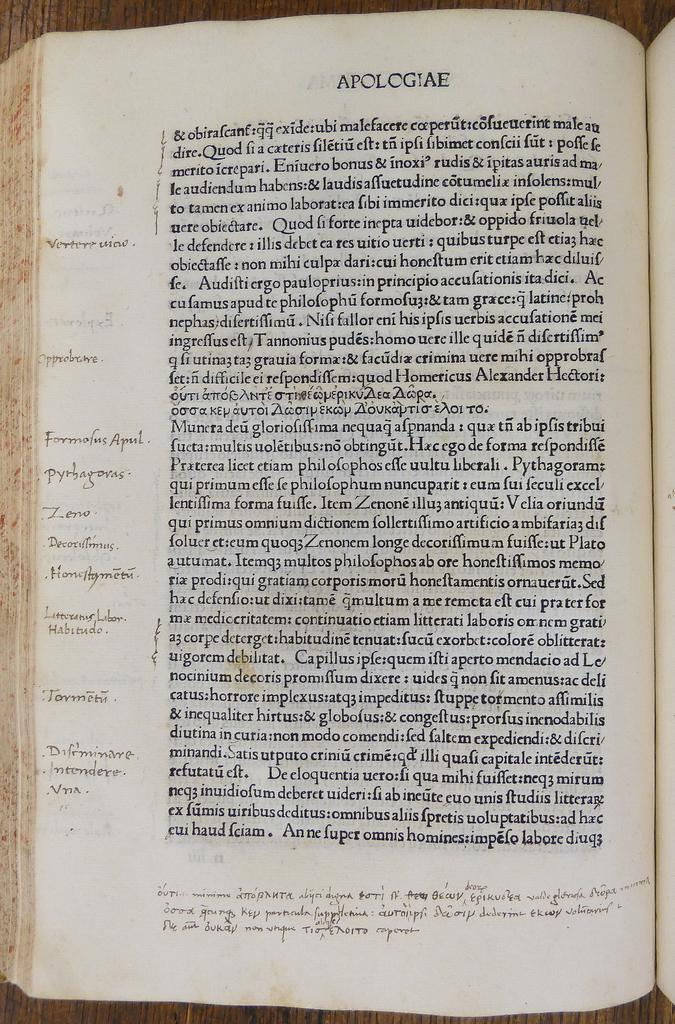What is present in the image related to reading material? There is a book in the image. Can you describe the state of the book? The book is opened. On what surface is the book placed? The book is placed on a wooden surface. What can be seen inside the book? There is text visible in the book. How many cats are sitting on the book in the image? There are no cats present in the image; the book is placed on a wooden surface. 